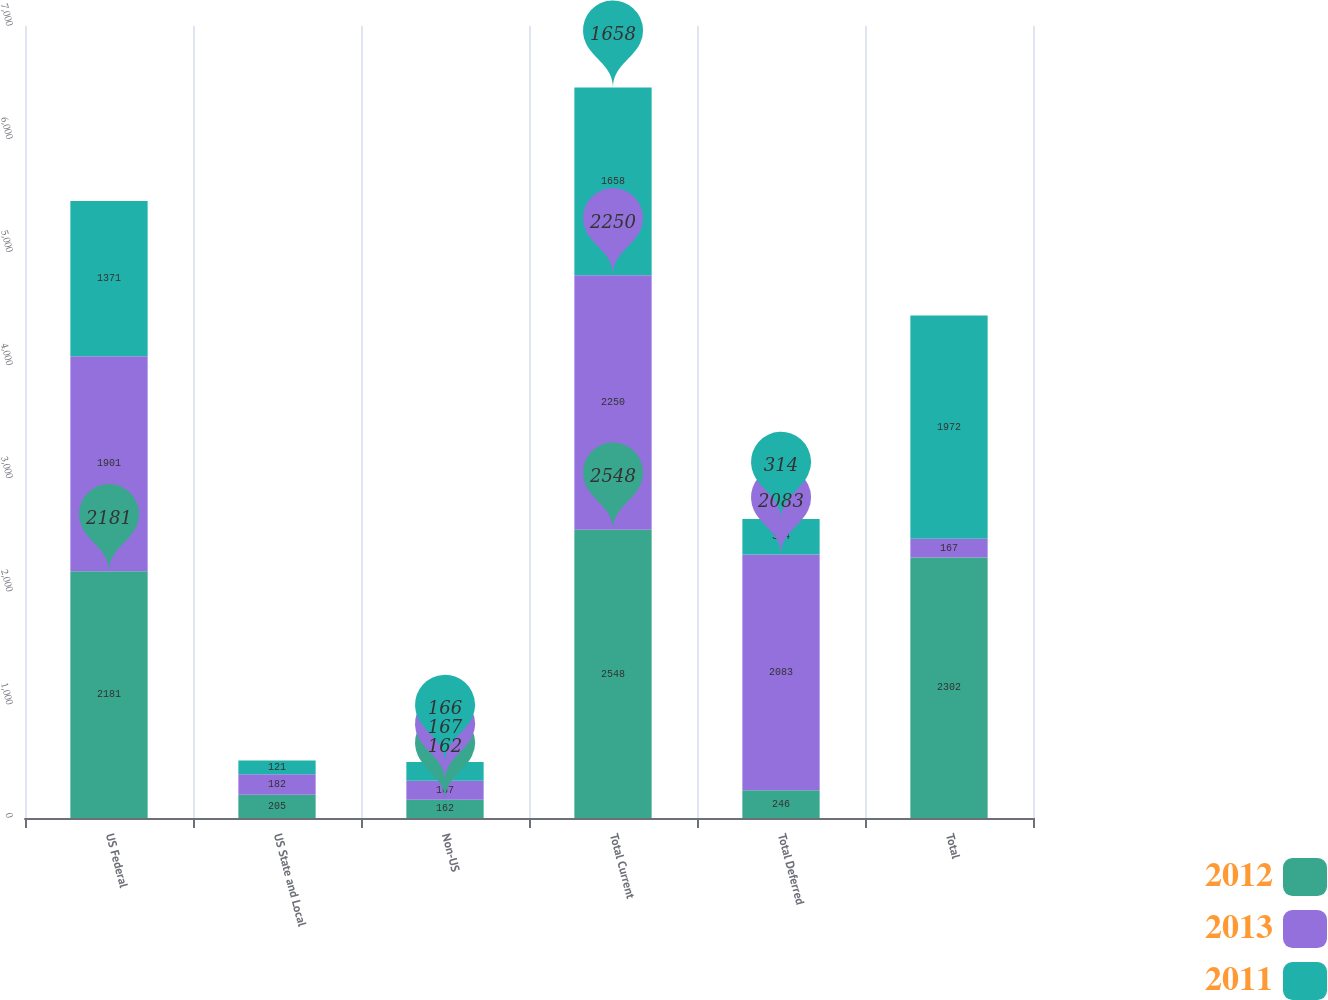Convert chart to OTSL. <chart><loc_0><loc_0><loc_500><loc_500><stacked_bar_chart><ecel><fcel>US Federal<fcel>US State and Local<fcel>Non-US<fcel>Total Current<fcel>Total Deferred<fcel>Total<nl><fcel>2012<fcel>2181<fcel>205<fcel>162<fcel>2548<fcel>246<fcel>2302<nl><fcel>2013<fcel>1901<fcel>182<fcel>167<fcel>2250<fcel>2083<fcel>167<nl><fcel>2011<fcel>1371<fcel>121<fcel>166<fcel>1658<fcel>314<fcel>1972<nl></chart> 